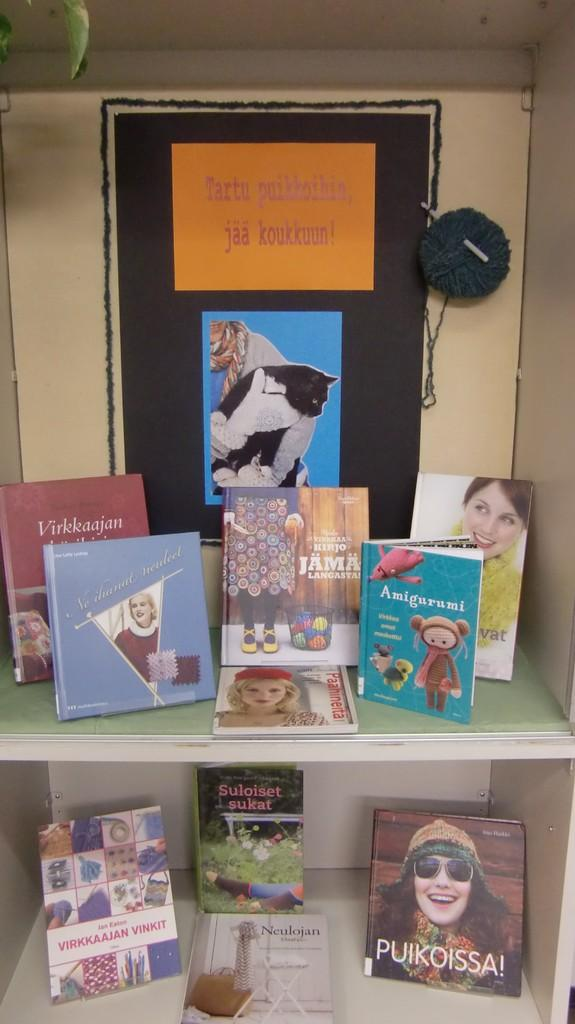<image>
Present a compact description of the photo's key features. The book on the bottom is titles Puikoissa! 